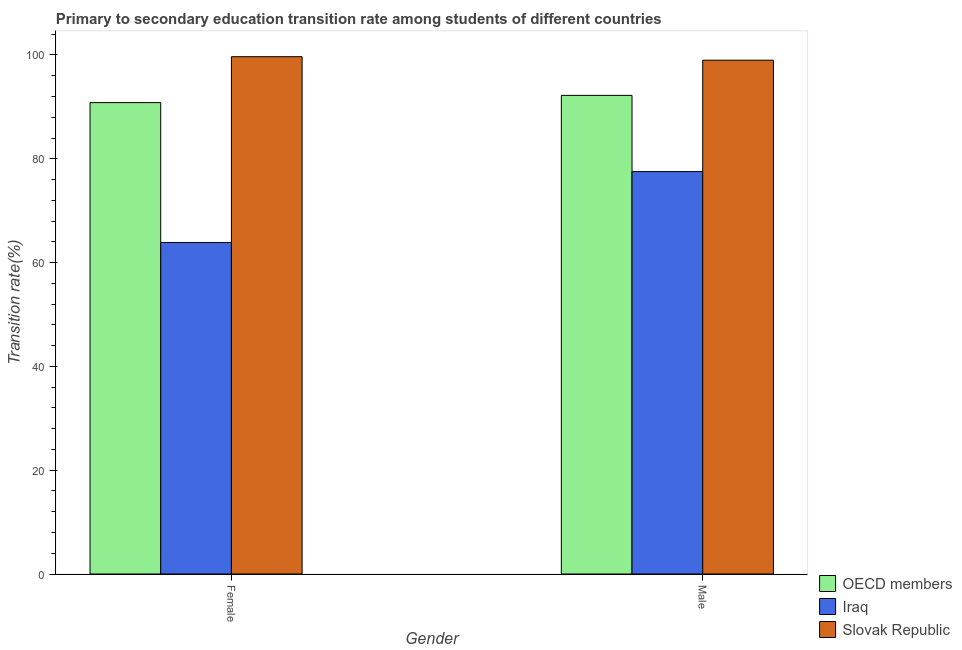How many different coloured bars are there?
Your answer should be compact. 3. How many bars are there on the 1st tick from the left?
Offer a very short reply. 3. What is the transition rate among female students in Iraq?
Provide a succinct answer. 63.87. Across all countries, what is the maximum transition rate among male students?
Keep it short and to the point. 99. Across all countries, what is the minimum transition rate among female students?
Make the answer very short. 63.87. In which country was the transition rate among male students maximum?
Your answer should be very brief. Slovak Republic. In which country was the transition rate among male students minimum?
Ensure brevity in your answer.  Iraq. What is the total transition rate among male students in the graph?
Offer a very short reply. 268.74. What is the difference between the transition rate among female students in Iraq and that in OECD members?
Give a very brief answer. -26.95. What is the difference between the transition rate among male students in Slovak Republic and the transition rate among female students in Iraq?
Offer a terse response. 35.12. What is the average transition rate among female students per country?
Keep it short and to the point. 84.79. What is the difference between the transition rate among female students and transition rate among male students in OECD members?
Provide a short and direct response. -1.39. What is the ratio of the transition rate among male students in Slovak Republic to that in OECD members?
Give a very brief answer. 1.07. In how many countries, is the transition rate among female students greater than the average transition rate among female students taken over all countries?
Your response must be concise. 2. What does the 2nd bar from the left in Male represents?
Ensure brevity in your answer.  Iraq. What does the 1st bar from the right in Male represents?
Your answer should be very brief. Slovak Republic. Are all the bars in the graph horizontal?
Make the answer very short. No. How many countries are there in the graph?
Your response must be concise. 3. Does the graph contain grids?
Make the answer very short. No. How are the legend labels stacked?
Give a very brief answer. Vertical. What is the title of the graph?
Provide a short and direct response. Primary to secondary education transition rate among students of different countries. Does "Macedonia" appear as one of the legend labels in the graph?
Provide a short and direct response. No. What is the label or title of the Y-axis?
Ensure brevity in your answer.  Transition rate(%). What is the Transition rate(%) of OECD members in Female?
Make the answer very short. 90.82. What is the Transition rate(%) in Iraq in Female?
Offer a terse response. 63.87. What is the Transition rate(%) in Slovak Republic in Female?
Your answer should be very brief. 99.67. What is the Transition rate(%) in OECD members in Male?
Provide a succinct answer. 92.21. What is the Transition rate(%) in Iraq in Male?
Your answer should be compact. 77.53. What is the Transition rate(%) in Slovak Republic in Male?
Keep it short and to the point. 99. Across all Gender, what is the maximum Transition rate(%) in OECD members?
Your answer should be compact. 92.21. Across all Gender, what is the maximum Transition rate(%) in Iraq?
Your answer should be compact. 77.53. Across all Gender, what is the maximum Transition rate(%) of Slovak Republic?
Make the answer very short. 99.67. Across all Gender, what is the minimum Transition rate(%) in OECD members?
Your response must be concise. 90.82. Across all Gender, what is the minimum Transition rate(%) of Iraq?
Provide a short and direct response. 63.87. Across all Gender, what is the minimum Transition rate(%) of Slovak Republic?
Your answer should be very brief. 99. What is the total Transition rate(%) of OECD members in the graph?
Make the answer very short. 183.03. What is the total Transition rate(%) of Iraq in the graph?
Keep it short and to the point. 141.4. What is the total Transition rate(%) in Slovak Republic in the graph?
Your answer should be very brief. 198.66. What is the difference between the Transition rate(%) in OECD members in Female and that in Male?
Your answer should be compact. -1.39. What is the difference between the Transition rate(%) of Iraq in Female and that in Male?
Provide a short and direct response. -13.66. What is the difference between the Transition rate(%) in Slovak Republic in Female and that in Male?
Make the answer very short. 0.67. What is the difference between the Transition rate(%) of OECD members in Female and the Transition rate(%) of Iraq in Male?
Provide a succinct answer. 13.29. What is the difference between the Transition rate(%) in OECD members in Female and the Transition rate(%) in Slovak Republic in Male?
Provide a succinct answer. -8.18. What is the difference between the Transition rate(%) of Iraq in Female and the Transition rate(%) of Slovak Republic in Male?
Offer a very short reply. -35.12. What is the average Transition rate(%) of OECD members per Gender?
Give a very brief answer. 91.52. What is the average Transition rate(%) of Iraq per Gender?
Your answer should be very brief. 70.7. What is the average Transition rate(%) in Slovak Republic per Gender?
Give a very brief answer. 99.33. What is the difference between the Transition rate(%) in OECD members and Transition rate(%) in Iraq in Female?
Ensure brevity in your answer.  26.95. What is the difference between the Transition rate(%) in OECD members and Transition rate(%) in Slovak Republic in Female?
Your answer should be compact. -8.85. What is the difference between the Transition rate(%) of Iraq and Transition rate(%) of Slovak Republic in Female?
Your answer should be compact. -35.8. What is the difference between the Transition rate(%) of OECD members and Transition rate(%) of Iraq in Male?
Make the answer very short. 14.69. What is the difference between the Transition rate(%) of OECD members and Transition rate(%) of Slovak Republic in Male?
Your answer should be very brief. -6.78. What is the difference between the Transition rate(%) in Iraq and Transition rate(%) in Slovak Republic in Male?
Provide a short and direct response. -21.47. What is the ratio of the Transition rate(%) of OECD members in Female to that in Male?
Your answer should be compact. 0.98. What is the ratio of the Transition rate(%) in Iraq in Female to that in Male?
Give a very brief answer. 0.82. What is the ratio of the Transition rate(%) of Slovak Republic in Female to that in Male?
Offer a terse response. 1.01. What is the difference between the highest and the second highest Transition rate(%) in OECD members?
Your response must be concise. 1.39. What is the difference between the highest and the second highest Transition rate(%) of Iraq?
Ensure brevity in your answer.  13.66. What is the difference between the highest and the second highest Transition rate(%) in Slovak Republic?
Your answer should be very brief. 0.67. What is the difference between the highest and the lowest Transition rate(%) of OECD members?
Your answer should be compact. 1.39. What is the difference between the highest and the lowest Transition rate(%) in Iraq?
Offer a very short reply. 13.66. What is the difference between the highest and the lowest Transition rate(%) of Slovak Republic?
Provide a succinct answer. 0.67. 